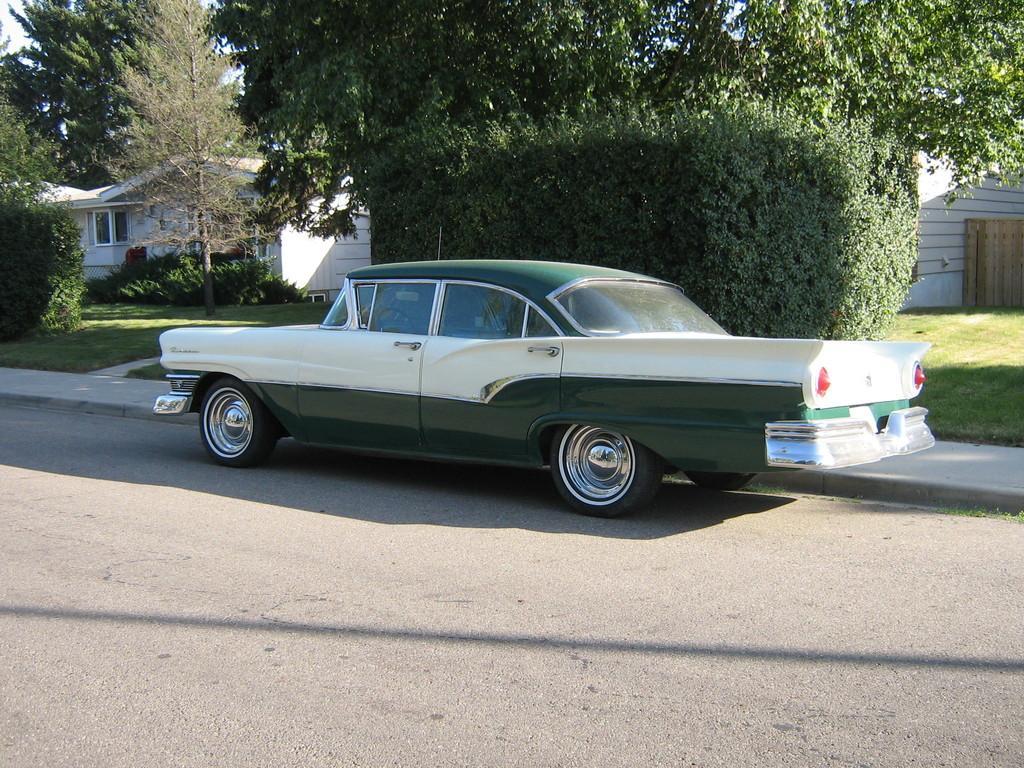Could you give a brief overview of what you see in this image? In this picture there is white and green color classic car parked on the roadside. Behind there are some trees and white color shade house. 